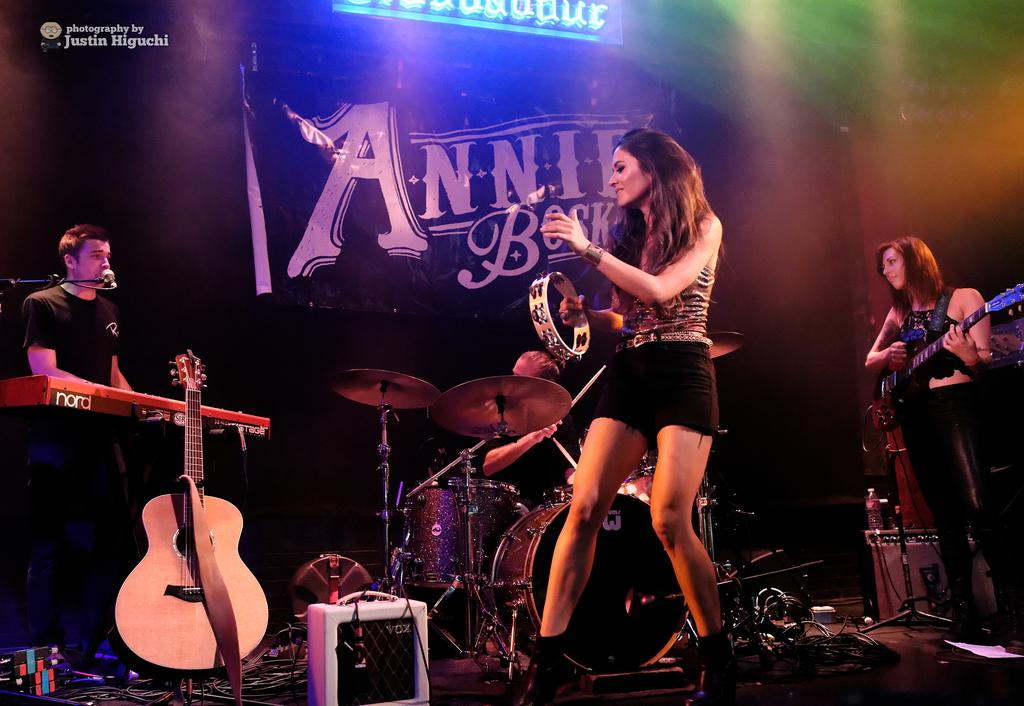What is the man in the image doing? The man is singing in the image. How is the man amplifying his voice in the image? The man is using a microphone in the image. What is the girl in the image doing? There is a girl dancing in the image, and another girl playing the guitar. How is the girl playing the guitar positioned in the image? The girl playing the guitar is standing in the image. Can you see any cobwebs in the image? There is no mention of cobwebs in the provided facts, and therefore we cannot determine their presence in the image. 